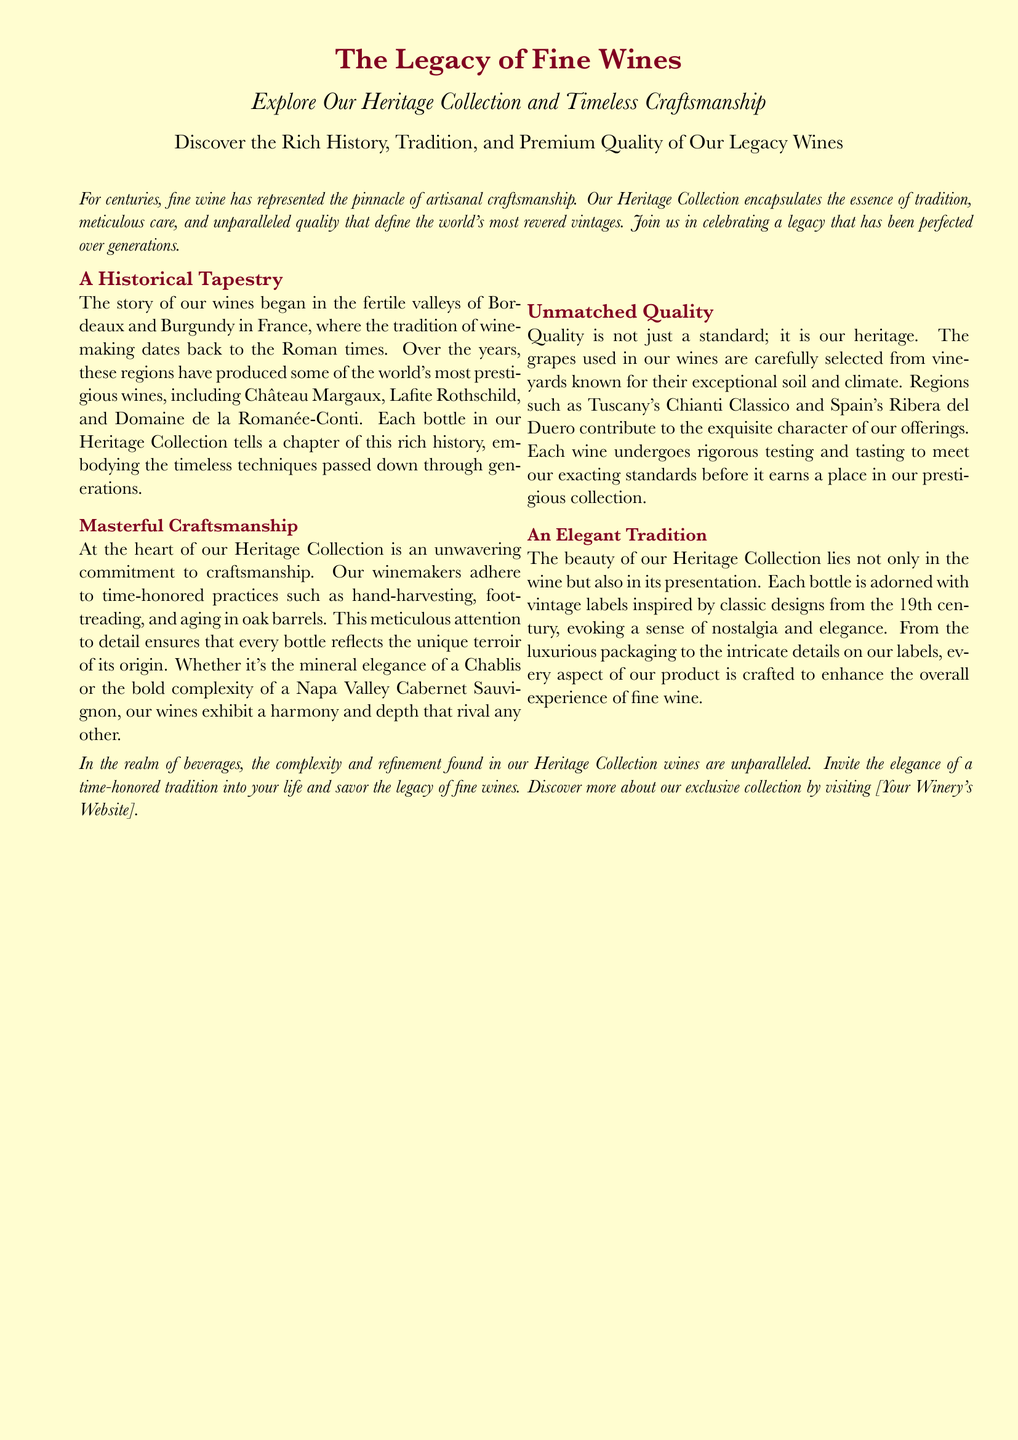What is the name of the collection highlighted in the document? The collection mentioned is the "Heritage Collection."
Answer: Heritage Collection In which regions did the story of these wines begin? The document states that the story began in the fertile valleys of "Bordeaux and Burgundy."
Answer: Bordeaux and Burgundy What type of practices do winemakers use in this collection? The document lists "hand-harvesting, foot-treading, and aging in oak barrels" as practices used.
Answer: hand-harvesting, foot-treading, and aging in oak barrels Which wine is associated with Napa Valley according to the document? The document mentions "Napa Valley Cabernet Sauvignon" as the wine associated with Napa Valley.
Answer: Napa Valley Cabernet Sauvignon What quality do the grapes in the Heritage Collection come from? The grapes are sourced from vineyards known for their "exceptional soil and climate."
Answer: exceptional soil and climate What is used for the presentation of the bottles? The bottles are adorned with "vintage labels inspired by classic designs from the 19th century."
Answer: vintage labels inspired by classic designs from the 19th century What is the document encouraging readers to do? The document encourages readers to "discover more about our exclusive collection."
Answer: discover more about our exclusive collection How does the document describe the tradition of fine wine? The document refers to it as "the pinnacle of artisanal craftsmanship."
Answer: the pinnacle of artisanal craftsmanship 